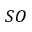<formula> <loc_0><loc_0><loc_500><loc_500>S O</formula> 